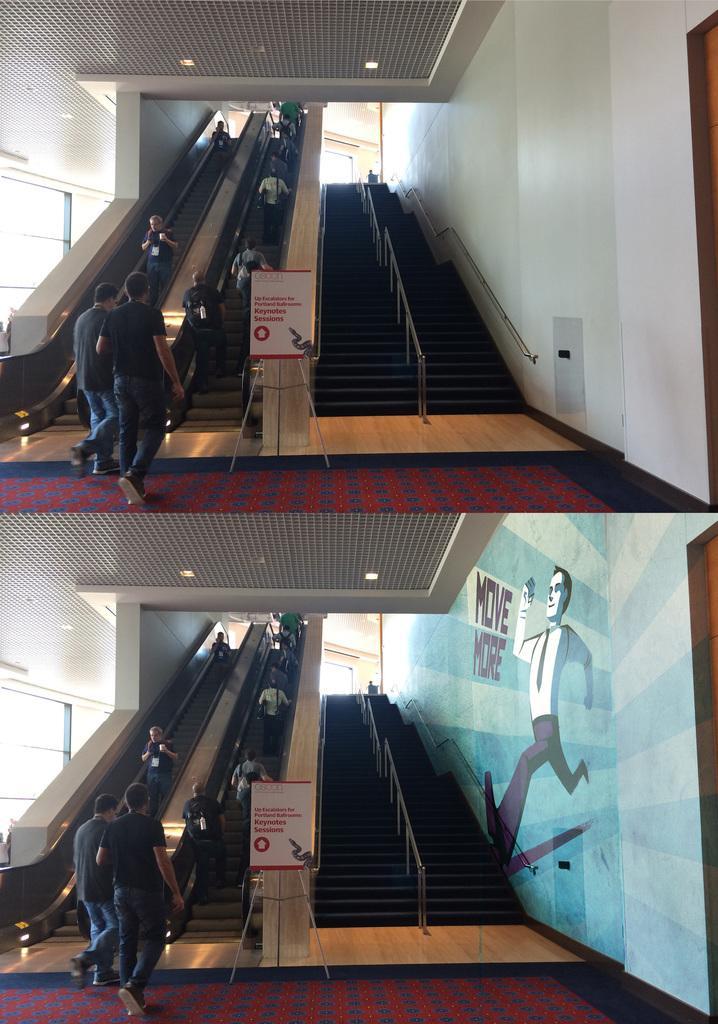Please provide a concise description of this image. This is collage picture, in these two pictures we can see people, escalators, boards with stands, lights, steps, railings and painting on the wall. 